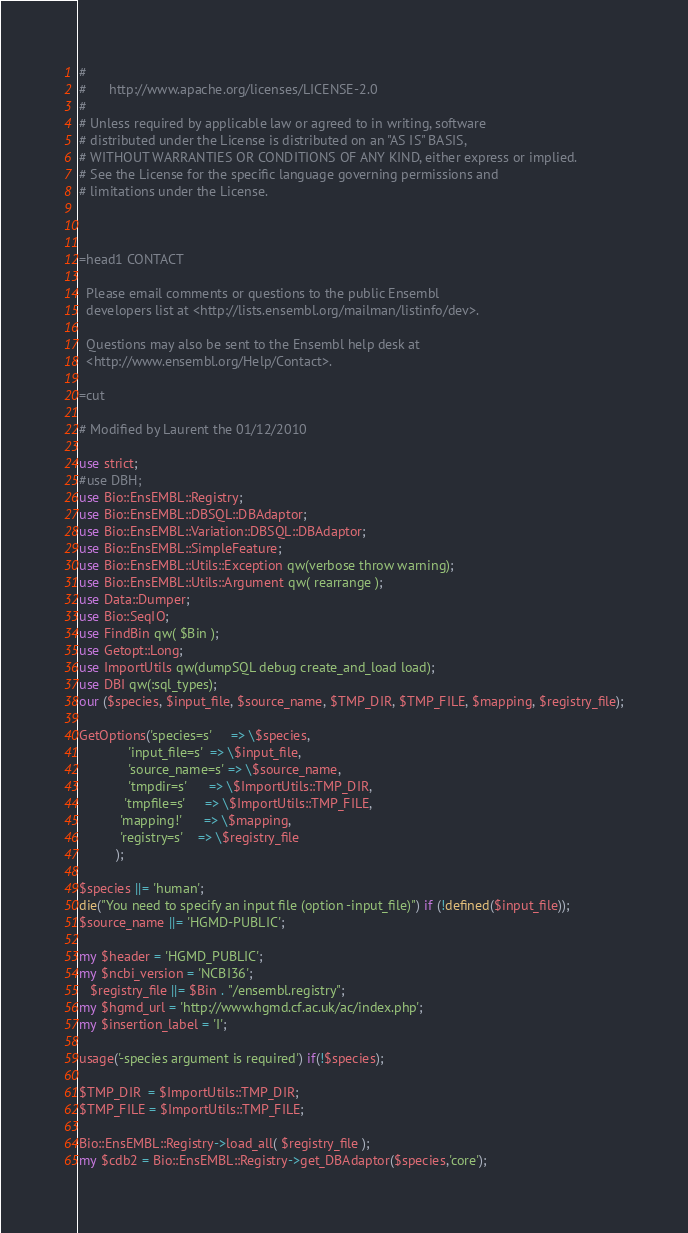<code> <loc_0><loc_0><loc_500><loc_500><_Perl_># 
#      http://www.apache.org/licenses/LICENSE-2.0
# 
# Unless required by applicable law or agreed to in writing, software
# distributed under the License is distributed on an "AS IS" BASIS,
# WITHOUT WARRANTIES OR CONDITIONS OF ANY KIND, either express or implied.
# See the License for the specific language governing permissions and
# limitations under the License.



=head1 CONTACT

  Please email comments or questions to the public Ensembl
  developers list at <http://lists.ensembl.org/mailman/listinfo/dev>.

  Questions may also be sent to the Ensembl help desk at
  <http://www.ensembl.org/Help/Contact>.

=cut

# Modified by Laurent the 01/12/2010

use strict;
#use DBH;
use Bio::EnsEMBL::Registry;
use Bio::EnsEMBL::DBSQL::DBAdaptor;
use Bio::EnsEMBL::Variation::DBSQL::DBAdaptor;
use Bio::EnsEMBL::SimpleFeature;
use Bio::EnsEMBL::Utils::Exception qw(verbose throw warning);
use Bio::EnsEMBL::Utils::Argument qw( rearrange );
use Data::Dumper;
use Bio::SeqIO;
use FindBin qw( $Bin );
use Getopt::Long;
use ImportUtils qw(dumpSQL debug create_and_load load);
use DBI qw(:sql_types);
our ($species, $input_file, $source_name, $TMP_DIR, $TMP_FILE, $mapping, $registry_file);

GetOptions('species=s'     => \$species,
             'input_file=s'  => \$input_file,
             'source_name=s' => \$source_name,
             'tmpdir=s'      => \$ImportUtils::TMP_DIR,
            'tmpfile=s'     => \$ImportUtils::TMP_FILE,
           'mapping!'      => \$mapping,
           'registry=s'    => \$registry_file
          );

$species ||= 'human';
die("You need to specify an input file (option -input_file)") if (!defined($input_file));
$source_name ||= 'HGMD-PUBLIC';

my $header = 'HGMD_PUBLIC';
my $ncbi_version = 'NCBI36';
   $registry_file ||= $Bin . "/ensembl.registry";
my $hgmd_url = 'http://www.hgmd.cf.ac.uk/ac/index.php';
my $insertion_label = 'I';

usage('-species argument is required') if(!$species);

$TMP_DIR  = $ImportUtils::TMP_DIR;
$TMP_FILE = $ImportUtils::TMP_FILE;

Bio::EnsEMBL::Registry->load_all( $registry_file );
my $cdb2 = Bio::EnsEMBL::Registry->get_DBAdaptor($species,'core');</code> 